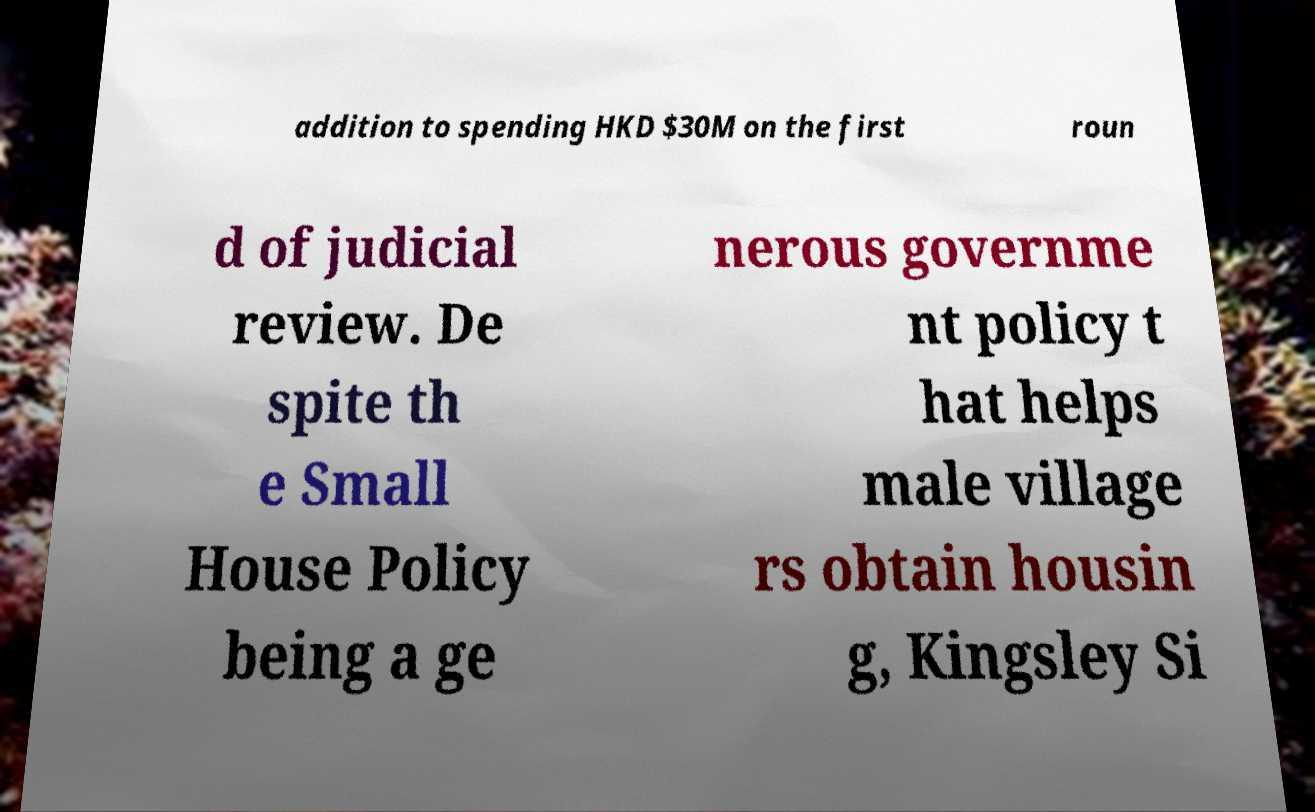Please read and relay the text visible in this image. What does it say? addition to spending HKD $30M on the first roun d of judicial review. De spite th e Small House Policy being a ge nerous governme nt policy t hat helps male village rs obtain housin g, Kingsley Si 